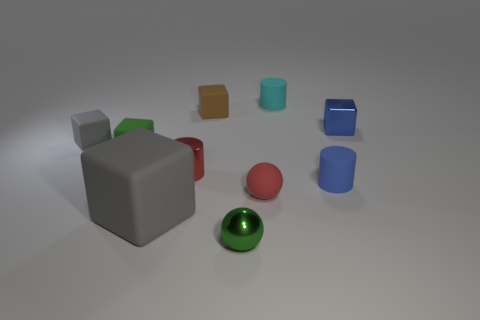Subtract all blue shiny cubes. How many cubes are left? 4 Subtract all brown cubes. How many cubes are left? 4 Subtract all brown blocks. Subtract all yellow cylinders. How many blocks are left? 4 Subtract all spheres. How many objects are left? 8 Add 3 tiny rubber spheres. How many tiny rubber spheres exist? 4 Subtract 0 cyan cubes. How many objects are left? 10 Subtract all tiny rubber blocks. Subtract all blue cylinders. How many objects are left? 6 Add 5 tiny green matte things. How many tiny green matte things are left? 6 